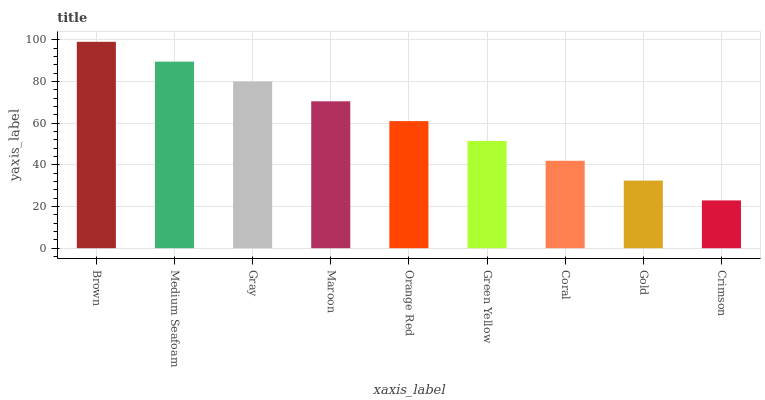Is Crimson the minimum?
Answer yes or no. Yes. Is Brown the maximum?
Answer yes or no. Yes. Is Medium Seafoam the minimum?
Answer yes or no. No. Is Medium Seafoam the maximum?
Answer yes or no. No. Is Brown greater than Medium Seafoam?
Answer yes or no. Yes. Is Medium Seafoam less than Brown?
Answer yes or no. Yes. Is Medium Seafoam greater than Brown?
Answer yes or no. No. Is Brown less than Medium Seafoam?
Answer yes or no. No. Is Orange Red the high median?
Answer yes or no. Yes. Is Orange Red the low median?
Answer yes or no. Yes. Is Crimson the high median?
Answer yes or no. No. Is Medium Seafoam the low median?
Answer yes or no. No. 